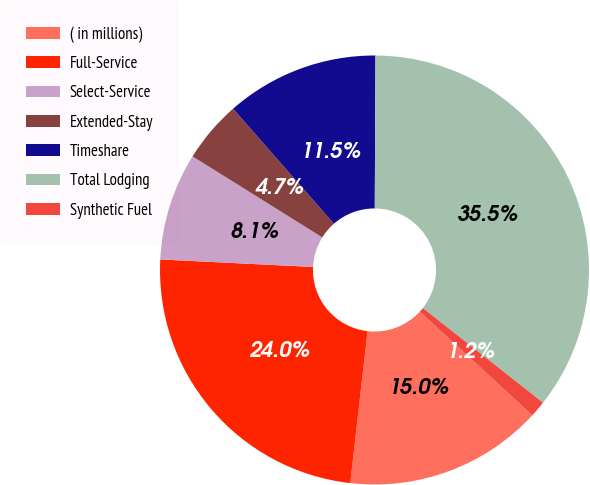Convert chart to OTSL. <chart><loc_0><loc_0><loc_500><loc_500><pie_chart><fcel>( in millions)<fcel>Full-Service<fcel>Select-Service<fcel>Extended-Stay<fcel>Timeshare<fcel>Total Lodging<fcel>Synthetic Fuel<nl><fcel>14.96%<fcel>23.98%<fcel>8.1%<fcel>4.66%<fcel>11.53%<fcel>35.55%<fcel>1.23%<nl></chart> 